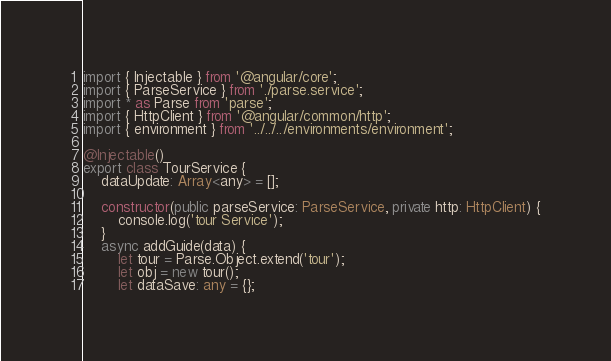<code> <loc_0><loc_0><loc_500><loc_500><_TypeScript_>import { Injectable } from '@angular/core';
import { ParseService } from './parse.service';
import * as Parse from 'parse';
import { HttpClient } from '@angular/common/http';
import { environment } from '../../../environments/environment';

@Injectable()
export class TourService {
    dataUpdate: Array<any> = [];

    constructor(public parseService: ParseService, private http: HttpClient) {
        console.log('tour Service');
    }
    async addGuide(data) {
        let tour = Parse.Object.extend('tour');
        let obj = new tour();
        let dataSave: any = {};</code> 